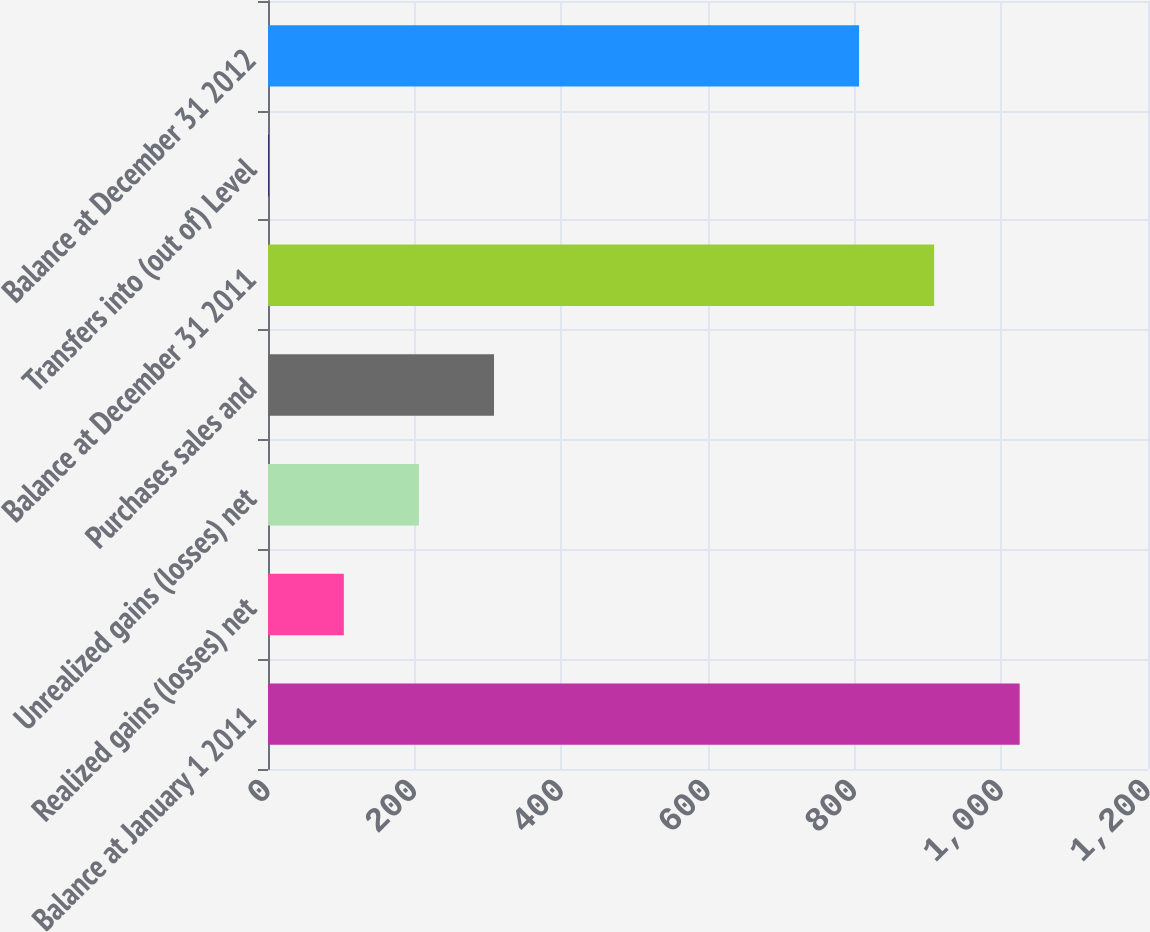<chart> <loc_0><loc_0><loc_500><loc_500><bar_chart><fcel>Balance at January 1 2011<fcel>Realized gains (losses) net<fcel>Unrealized gains (losses) net<fcel>Purchases sales and<fcel>Balance at December 31 2011<fcel>Transfers into (out of) Level<fcel>Balance at December 31 2012<nl><fcel>1025<fcel>103.4<fcel>205.8<fcel>308.2<fcel>908.4<fcel>1<fcel>806<nl></chart> 